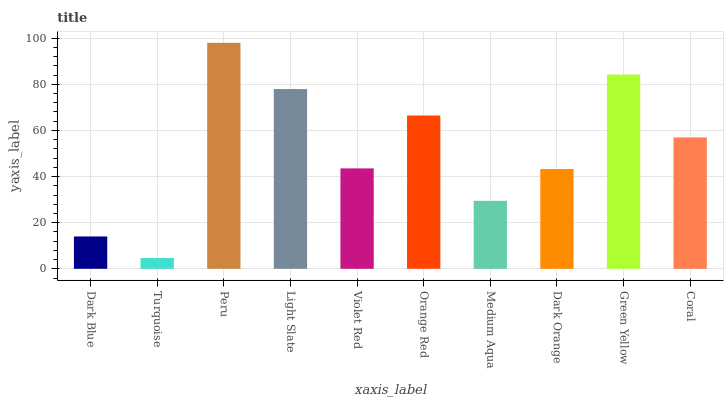Is Peru the minimum?
Answer yes or no. No. Is Turquoise the maximum?
Answer yes or no. No. Is Peru greater than Turquoise?
Answer yes or no. Yes. Is Turquoise less than Peru?
Answer yes or no. Yes. Is Turquoise greater than Peru?
Answer yes or no. No. Is Peru less than Turquoise?
Answer yes or no. No. Is Coral the high median?
Answer yes or no. Yes. Is Violet Red the low median?
Answer yes or no. Yes. Is Dark Blue the high median?
Answer yes or no. No. Is Green Yellow the low median?
Answer yes or no. No. 